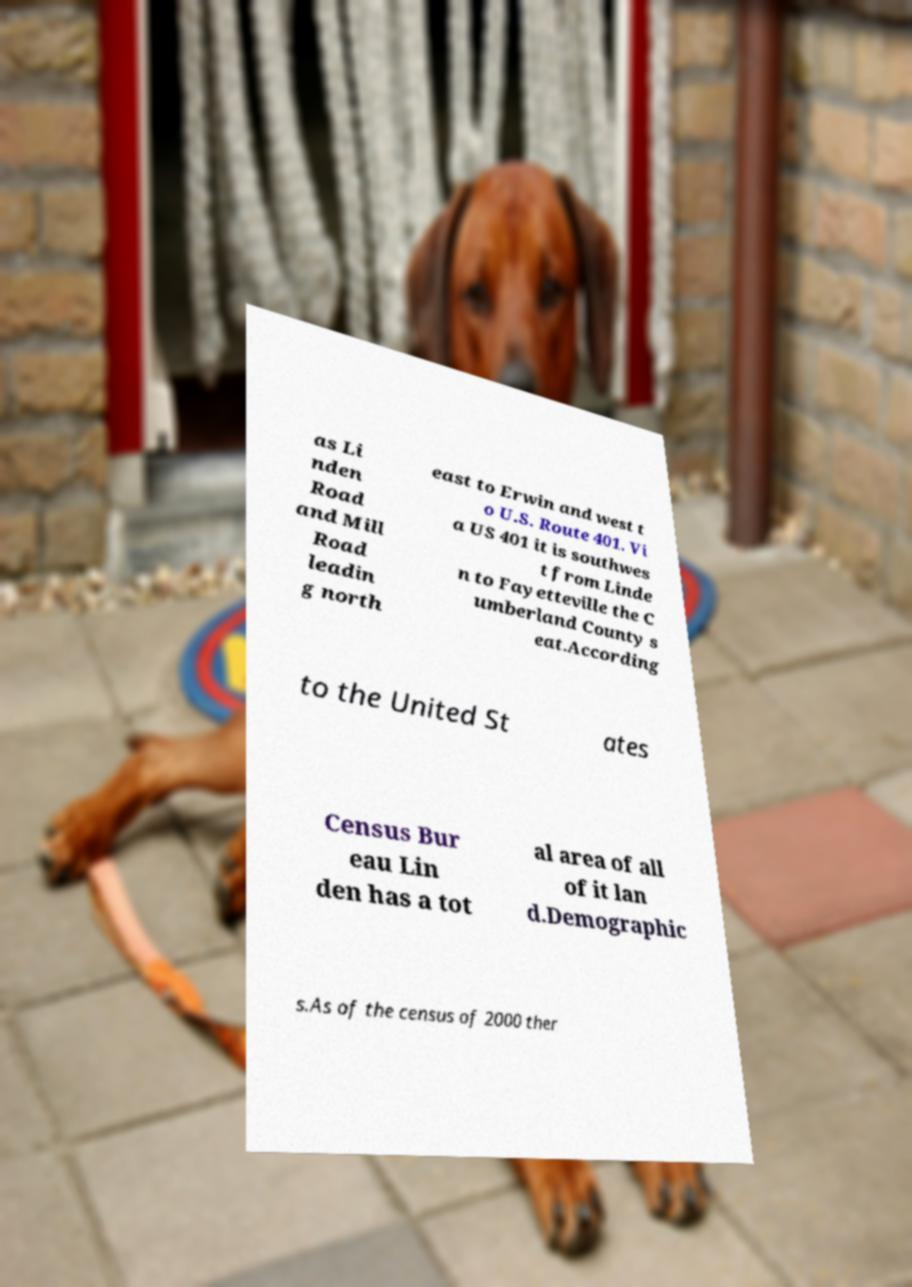Could you assist in decoding the text presented in this image and type it out clearly? as Li nden Road and Mill Road leadin g north east to Erwin and west t o U.S. Route 401. Vi a US 401 it is southwes t from Linde n to Fayetteville the C umberland County s eat.According to the United St ates Census Bur eau Lin den has a tot al area of all of it lan d.Demographic s.As of the census of 2000 ther 